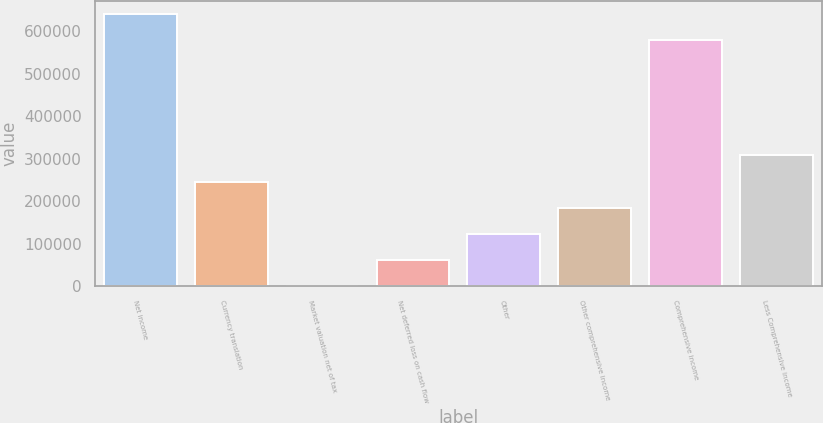<chart> <loc_0><loc_0><loc_500><loc_500><bar_chart><fcel>Net income<fcel>Currency translation<fcel>Market valuation net of tax<fcel>Net deferred loss on cash flow<fcel>Other<fcel>Other comprehensive income<fcel>Comprehensive income<fcel>Less Comprehensive income<nl><fcel>639558<fcel>245820<fcel>20<fcel>61470.1<fcel>122920<fcel>184370<fcel>578108<fcel>307270<nl></chart> 